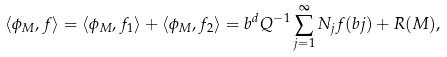Convert formula to latex. <formula><loc_0><loc_0><loc_500><loc_500>\langle \phi _ { M } , f \rangle = \langle \phi _ { M } , f _ { 1 } \rangle + \langle \phi _ { M } , f _ { 2 } \rangle = b ^ { d } Q ^ { - 1 } \sum _ { j = 1 } ^ { \infty } N _ { j } f ( b j ) + R ( M ) ,</formula> 